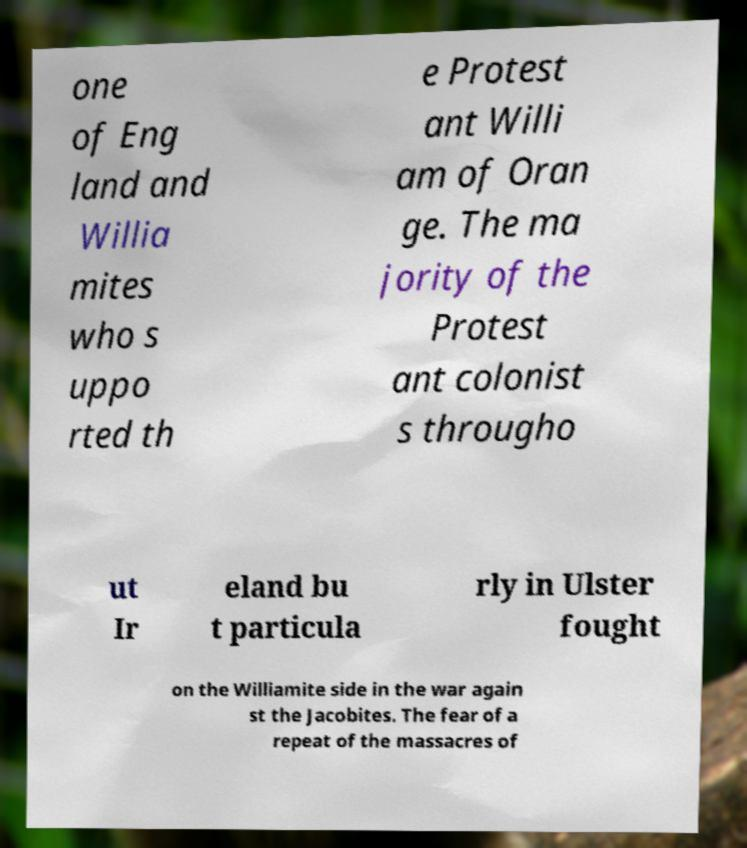Please read and relay the text visible in this image. What does it say? one of Eng land and Willia mites who s uppo rted th e Protest ant Willi am of Oran ge. The ma jority of the Protest ant colonist s througho ut Ir eland bu t particula rly in Ulster fought on the Williamite side in the war again st the Jacobites. The fear of a repeat of the massacres of 